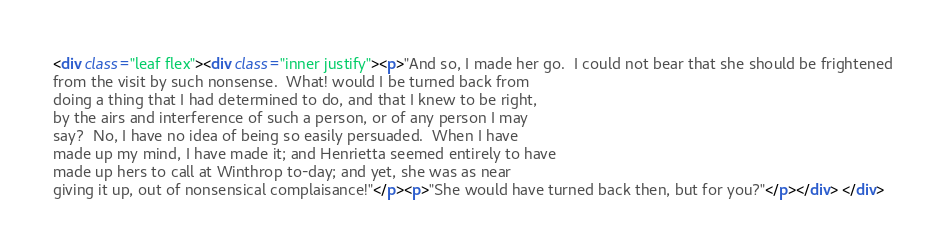Convert code to text. <code><loc_0><loc_0><loc_500><loc_500><_HTML_><div class="leaf flex"><div class="inner justify"><p>"And so, I made her go.  I could not bear that she should be frightened
from the visit by such nonsense.  What! would I be turned back from
doing a thing that I had determined to do, and that I knew to be right,
by the airs and interference of such a person, or of any person I may
say?  No, I have no idea of being so easily persuaded.  When I have
made up my mind, I have made it; and Henrietta seemed entirely to have
made up hers to call at Winthrop to-day; and yet, she was as near
giving it up, out of nonsensical complaisance!"</p><p>"She would have turned back then, but for you?"</p></div> </div></code> 